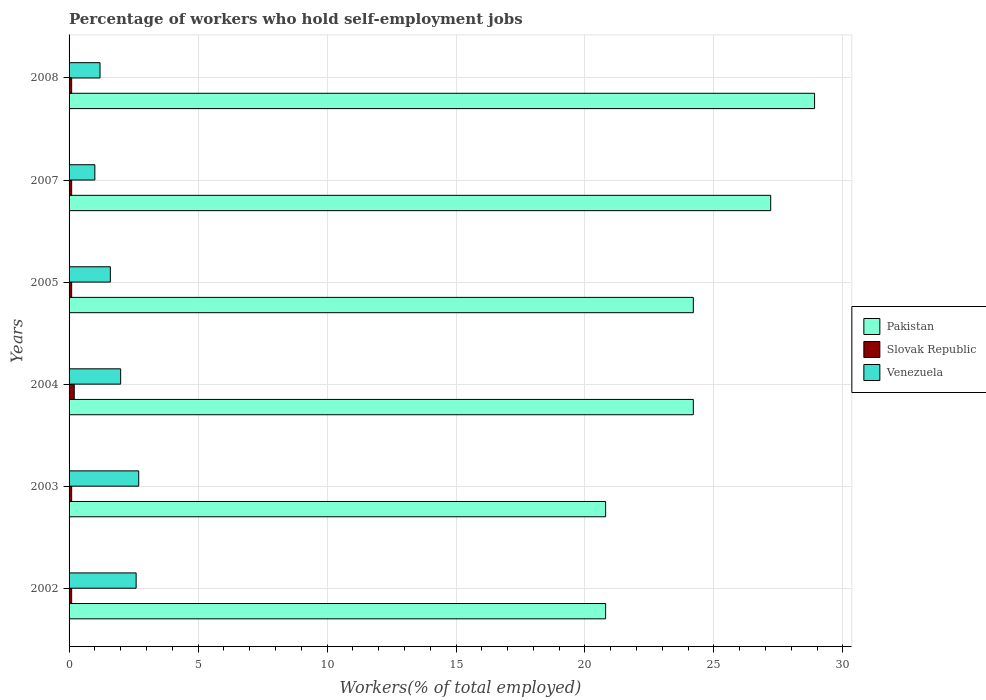How many different coloured bars are there?
Your response must be concise. 3. Are the number of bars per tick equal to the number of legend labels?
Ensure brevity in your answer.  Yes. How many bars are there on the 3rd tick from the top?
Your response must be concise. 3. What is the label of the 5th group of bars from the top?
Provide a succinct answer. 2003. In how many cases, is the number of bars for a given year not equal to the number of legend labels?
Offer a terse response. 0. What is the percentage of self-employed workers in Slovak Republic in 2003?
Make the answer very short. 0.1. Across all years, what is the maximum percentage of self-employed workers in Slovak Republic?
Offer a terse response. 0.2. Across all years, what is the minimum percentage of self-employed workers in Venezuela?
Your response must be concise. 1. In which year was the percentage of self-employed workers in Pakistan maximum?
Your answer should be compact. 2008. What is the total percentage of self-employed workers in Slovak Republic in the graph?
Ensure brevity in your answer.  0.7. What is the difference between the percentage of self-employed workers in Pakistan in 2002 and that in 2003?
Make the answer very short. 0. What is the difference between the percentage of self-employed workers in Pakistan in 2004 and the percentage of self-employed workers in Venezuela in 2005?
Make the answer very short. 22.6. What is the average percentage of self-employed workers in Pakistan per year?
Make the answer very short. 24.35. In the year 2008, what is the difference between the percentage of self-employed workers in Pakistan and percentage of self-employed workers in Venezuela?
Ensure brevity in your answer.  27.7. In how many years, is the percentage of self-employed workers in Pakistan greater than 3 %?
Offer a very short reply. 6. What is the ratio of the percentage of self-employed workers in Pakistan in 2005 to that in 2007?
Provide a short and direct response. 0.89. Is the percentage of self-employed workers in Slovak Republic in 2004 less than that in 2005?
Provide a succinct answer. No. Is the difference between the percentage of self-employed workers in Pakistan in 2004 and 2008 greater than the difference between the percentage of self-employed workers in Venezuela in 2004 and 2008?
Ensure brevity in your answer.  No. What is the difference between the highest and the second highest percentage of self-employed workers in Slovak Republic?
Your response must be concise. 0.1. What is the difference between the highest and the lowest percentage of self-employed workers in Venezuela?
Make the answer very short. 1.7. In how many years, is the percentage of self-employed workers in Slovak Republic greater than the average percentage of self-employed workers in Slovak Republic taken over all years?
Make the answer very short. 1. Is the sum of the percentage of self-employed workers in Pakistan in 2005 and 2008 greater than the maximum percentage of self-employed workers in Venezuela across all years?
Your answer should be very brief. Yes. What does the 3rd bar from the bottom in 2004 represents?
Your answer should be compact. Venezuela. How many bars are there?
Provide a short and direct response. 18. Does the graph contain any zero values?
Your answer should be compact. No. Does the graph contain grids?
Provide a short and direct response. Yes. What is the title of the graph?
Your answer should be compact. Percentage of workers who hold self-employment jobs. What is the label or title of the X-axis?
Provide a short and direct response. Workers(% of total employed). What is the Workers(% of total employed) in Pakistan in 2002?
Ensure brevity in your answer.  20.8. What is the Workers(% of total employed) of Slovak Republic in 2002?
Offer a terse response. 0.1. What is the Workers(% of total employed) of Venezuela in 2002?
Make the answer very short. 2.6. What is the Workers(% of total employed) in Pakistan in 2003?
Offer a very short reply. 20.8. What is the Workers(% of total employed) in Slovak Republic in 2003?
Provide a succinct answer. 0.1. What is the Workers(% of total employed) in Venezuela in 2003?
Offer a very short reply. 2.7. What is the Workers(% of total employed) in Pakistan in 2004?
Keep it short and to the point. 24.2. What is the Workers(% of total employed) in Slovak Republic in 2004?
Offer a terse response. 0.2. What is the Workers(% of total employed) of Pakistan in 2005?
Offer a terse response. 24.2. What is the Workers(% of total employed) in Slovak Republic in 2005?
Provide a short and direct response. 0.1. What is the Workers(% of total employed) of Venezuela in 2005?
Your answer should be very brief. 1.6. What is the Workers(% of total employed) in Pakistan in 2007?
Offer a very short reply. 27.2. What is the Workers(% of total employed) in Slovak Republic in 2007?
Your answer should be compact. 0.1. What is the Workers(% of total employed) of Venezuela in 2007?
Provide a succinct answer. 1. What is the Workers(% of total employed) of Pakistan in 2008?
Make the answer very short. 28.9. What is the Workers(% of total employed) in Slovak Republic in 2008?
Provide a succinct answer. 0.1. What is the Workers(% of total employed) in Venezuela in 2008?
Provide a short and direct response. 1.2. Across all years, what is the maximum Workers(% of total employed) in Pakistan?
Keep it short and to the point. 28.9. Across all years, what is the maximum Workers(% of total employed) of Slovak Republic?
Provide a short and direct response. 0.2. Across all years, what is the maximum Workers(% of total employed) of Venezuela?
Your answer should be compact. 2.7. Across all years, what is the minimum Workers(% of total employed) in Pakistan?
Give a very brief answer. 20.8. Across all years, what is the minimum Workers(% of total employed) of Slovak Republic?
Give a very brief answer. 0.1. What is the total Workers(% of total employed) in Pakistan in the graph?
Give a very brief answer. 146.1. What is the total Workers(% of total employed) in Slovak Republic in the graph?
Your answer should be very brief. 0.7. What is the difference between the Workers(% of total employed) of Slovak Republic in 2002 and that in 2003?
Provide a succinct answer. 0. What is the difference between the Workers(% of total employed) of Pakistan in 2002 and that in 2004?
Your answer should be very brief. -3.4. What is the difference between the Workers(% of total employed) of Venezuela in 2002 and that in 2004?
Your response must be concise. 0.6. What is the difference between the Workers(% of total employed) of Slovak Republic in 2002 and that in 2005?
Ensure brevity in your answer.  0. What is the difference between the Workers(% of total employed) of Pakistan in 2002 and that in 2007?
Offer a very short reply. -6.4. What is the difference between the Workers(% of total employed) in Slovak Republic in 2002 and that in 2007?
Provide a short and direct response. 0. What is the difference between the Workers(% of total employed) in Slovak Republic in 2002 and that in 2008?
Provide a short and direct response. 0. What is the difference between the Workers(% of total employed) of Venezuela in 2003 and that in 2004?
Provide a short and direct response. 0.7. What is the difference between the Workers(% of total employed) of Slovak Republic in 2003 and that in 2005?
Provide a succinct answer. 0. What is the difference between the Workers(% of total employed) in Venezuela in 2003 and that in 2005?
Your response must be concise. 1.1. What is the difference between the Workers(% of total employed) in Pakistan in 2003 and that in 2007?
Keep it short and to the point. -6.4. What is the difference between the Workers(% of total employed) of Slovak Republic in 2003 and that in 2007?
Offer a terse response. 0. What is the difference between the Workers(% of total employed) in Venezuela in 2003 and that in 2008?
Your answer should be very brief. 1.5. What is the difference between the Workers(% of total employed) in Pakistan in 2004 and that in 2005?
Ensure brevity in your answer.  0. What is the difference between the Workers(% of total employed) in Slovak Republic in 2004 and that in 2005?
Give a very brief answer. 0.1. What is the difference between the Workers(% of total employed) in Venezuela in 2004 and that in 2005?
Your answer should be very brief. 0.4. What is the difference between the Workers(% of total employed) of Venezuela in 2004 and that in 2007?
Provide a short and direct response. 1. What is the difference between the Workers(% of total employed) in Pakistan in 2004 and that in 2008?
Keep it short and to the point. -4.7. What is the difference between the Workers(% of total employed) of Slovak Republic in 2004 and that in 2008?
Your answer should be very brief. 0.1. What is the difference between the Workers(% of total employed) in Pakistan in 2005 and that in 2007?
Ensure brevity in your answer.  -3. What is the difference between the Workers(% of total employed) in Slovak Republic in 2005 and that in 2007?
Your answer should be compact. 0. What is the difference between the Workers(% of total employed) in Pakistan in 2005 and that in 2008?
Keep it short and to the point. -4.7. What is the difference between the Workers(% of total employed) in Pakistan in 2007 and that in 2008?
Offer a terse response. -1.7. What is the difference between the Workers(% of total employed) in Slovak Republic in 2007 and that in 2008?
Provide a short and direct response. 0. What is the difference between the Workers(% of total employed) in Venezuela in 2007 and that in 2008?
Provide a succinct answer. -0.2. What is the difference between the Workers(% of total employed) in Pakistan in 2002 and the Workers(% of total employed) in Slovak Republic in 2003?
Provide a succinct answer. 20.7. What is the difference between the Workers(% of total employed) in Pakistan in 2002 and the Workers(% of total employed) in Slovak Republic in 2004?
Your answer should be compact. 20.6. What is the difference between the Workers(% of total employed) in Pakistan in 2002 and the Workers(% of total employed) in Slovak Republic in 2005?
Make the answer very short. 20.7. What is the difference between the Workers(% of total employed) in Pakistan in 2002 and the Workers(% of total employed) in Slovak Republic in 2007?
Offer a terse response. 20.7. What is the difference between the Workers(% of total employed) of Pakistan in 2002 and the Workers(% of total employed) of Venezuela in 2007?
Your response must be concise. 19.8. What is the difference between the Workers(% of total employed) of Slovak Republic in 2002 and the Workers(% of total employed) of Venezuela in 2007?
Provide a short and direct response. -0.9. What is the difference between the Workers(% of total employed) of Pakistan in 2002 and the Workers(% of total employed) of Slovak Republic in 2008?
Your answer should be compact. 20.7. What is the difference between the Workers(% of total employed) in Pakistan in 2002 and the Workers(% of total employed) in Venezuela in 2008?
Your answer should be compact. 19.6. What is the difference between the Workers(% of total employed) of Pakistan in 2003 and the Workers(% of total employed) of Slovak Republic in 2004?
Your response must be concise. 20.6. What is the difference between the Workers(% of total employed) of Pakistan in 2003 and the Workers(% of total employed) of Slovak Republic in 2005?
Your answer should be very brief. 20.7. What is the difference between the Workers(% of total employed) of Pakistan in 2003 and the Workers(% of total employed) of Venezuela in 2005?
Keep it short and to the point. 19.2. What is the difference between the Workers(% of total employed) of Slovak Republic in 2003 and the Workers(% of total employed) of Venezuela in 2005?
Offer a terse response. -1.5. What is the difference between the Workers(% of total employed) of Pakistan in 2003 and the Workers(% of total employed) of Slovak Republic in 2007?
Provide a succinct answer. 20.7. What is the difference between the Workers(% of total employed) in Pakistan in 2003 and the Workers(% of total employed) in Venezuela in 2007?
Make the answer very short. 19.8. What is the difference between the Workers(% of total employed) in Slovak Republic in 2003 and the Workers(% of total employed) in Venezuela in 2007?
Provide a succinct answer. -0.9. What is the difference between the Workers(% of total employed) of Pakistan in 2003 and the Workers(% of total employed) of Slovak Republic in 2008?
Give a very brief answer. 20.7. What is the difference between the Workers(% of total employed) of Pakistan in 2003 and the Workers(% of total employed) of Venezuela in 2008?
Give a very brief answer. 19.6. What is the difference between the Workers(% of total employed) of Slovak Republic in 2003 and the Workers(% of total employed) of Venezuela in 2008?
Offer a very short reply. -1.1. What is the difference between the Workers(% of total employed) in Pakistan in 2004 and the Workers(% of total employed) in Slovak Republic in 2005?
Offer a terse response. 24.1. What is the difference between the Workers(% of total employed) in Pakistan in 2004 and the Workers(% of total employed) in Venezuela in 2005?
Make the answer very short. 22.6. What is the difference between the Workers(% of total employed) of Slovak Republic in 2004 and the Workers(% of total employed) of Venezuela in 2005?
Provide a short and direct response. -1.4. What is the difference between the Workers(% of total employed) in Pakistan in 2004 and the Workers(% of total employed) in Slovak Republic in 2007?
Offer a terse response. 24.1. What is the difference between the Workers(% of total employed) in Pakistan in 2004 and the Workers(% of total employed) in Venezuela in 2007?
Your answer should be compact. 23.2. What is the difference between the Workers(% of total employed) in Pakistan in 2004 and the Workers(% of total employed) in Slovak Republic in 2008?
Your response must be concise. 24.1. What is the difference between the Workers(% of total employed) in Pakistan in 2004 and the Workers(% of total employed) in Venezuela in 2008?
Provide a short and direct response. 23. What is the difference between the Workers(% of total employed) in Pakistan in 2005 and the Workers(% of total employed) in Slovak Republic in 2007?
Give a very brief answer. 24.1. What is the difference between the Workers(% of total employed) of Pakistan in 2005 and the Workers(% of total employed) of Venezuela in 2007?
Your answer should be very brief. 23.2. What is the difference between the Workers(% of total employed) of Pakistan in 2005 and the Workers(% of total employed) of Slovak Republic in 2008?
Make the answer very short. 24.1. What is the difference between the Workers(% of total employed) of Pakistan in 2007 and the Workers(% of total employed) of Slovak Republic in 2008?
Make the answer very short. 27.1. What is the difference between the Workers(% of total employed) of Pakistan in 2007 and the Workers(% of total employed) of Venezuela in 2008?
Provide a short and direct response. 26. What is the difference between the Workers(% of total employed) in Slovak Republic in 2007 and the Workers(% of total employed) in Venezuela in 2008?
Provide a succinct answer. -1.1. What is the average Workers(% of total employed) of Pakistan per year?
Your answer should be very brief. 24.35. What is the average Workers(% of total employed) in Slovak Republic per year?
Your answer should be compact. 0.12. What is the average Workers(% of total employed) in Venezuela per year?
Offer a terse response. 1.85. In the year 2002, what is the difference between the Workers(% of total employed) of Pakistan and Workers(% of total employed) of Slovak Republic?
Keep it short and to the point. 20.7. In the year 2003, what is the difference between the Workers(% of total employed) of Pakistan and Workers(% of total employed) of Slovak Republic?
Provide a short and direct response. 20.7. In the year 2003, what is the difference between the Workers(% of total employed) in Pakistan and Workers(% of total employed) in Venezuela?
Offer a very short reply. 18.1. In the year 2004, what is the difference between the Workers(% of total employed) in Slovak Republic and Workers(% of total employed) in Venezuela?
Your answer should be very brief. -1.8. In the year 2005, what is the difference between the Workers(% of total employed) of Pakistan and Workers(% of total employed) of Slovak Republic?
Make the answer very short. 24.1. In the year 2005, what is the difference between the Workers(% of total employed) in Pakistan and Workers(% of total employed) in Venezuela?
Make the answer very short. 22.6. In the year 2005, what is the difference between the Workers(% of total employed) in Slovak Republic and Workers(% of total employed) in Venezuela?
Make the answer very short. -1.5. In the year 2007, what is the difference between the Workers(% of total employed) in Pakistan and Workers(% of total employed) in Slovak Republic?
Keep it short and to the point. 27.1. In the year 2007, what is the difference between the Workers(% of total employed) of Pakistan and Workers(% of total employed) of Venezuela?
Give a very brief answer. 26.2. In the year 2008, what is the difference between the Workers(% of total employed) in Pakistan and Workers(% of total employed) in Slovak Republic?
Your answer should be very brief. 28.8. In the year 2008, what is the difference between the Workers(% of total employed) of Pakistan and Workers(% of total employed) of Venezuela?
Your answer should be compact. 27.7. What is the ratio of the Workers(% of total employed) of Slovak Republic in 2002 to that in 2003?
Your answer should be compact. 1. What is the ratio of the Workers(% of total employed) in Pakistan in 2002 to that in 2004?
Your answer should be compact. 0.86. What is the ratio of the Workers(% of total employed) of Slovak Republic in 2002 to that in 2004?
Provide a short and direct response. 0.5. What is the ratio of the Workers(% of total employed) of Pakistan in 2002 to that in 2005?
Keep it short and to the point. 0.86. What is the ratio of the Workers(% of total employed) in Slovak Republic in 2002 to that in 2005?
Give a very brief answer. 1. What is the ratio of the Workers(% of total employed) of Venezuela in 2002 to that in 2005?
Provide a short and direct response. 1.62. What is the ratio of the Workers(% of total employed) of Pakistan in 2002 to that in 2007?
Keep it short and to the point. 0.76. What is the ratio of the Workers(% of total employed) of Slovak Republic in 2002 to that in 2007?
Offer a terse response. 1. What is the ratio of the Workers(% of total employed) of Venezuela in 2002 to that in 2007?
Offer a very short reply. 2.6. What is the ratio of the Workers(% of total employed) of Pakistan in 2002 to that in 2008?
Your answer should be compact. 0.72. What is the ratio of the Workers(% of total employed) in Venezuela in 2002 to that in 2008?
Provide a succinct answer. 2.17. What is the ratio of the Workers(% of total employed) of Pakistan in 2003 to that in 2004?
Keep it short and to the point. 0.86. What is the ratio of the Workers(% of total employed) in Venezuela in 2003 to that in 2004?
Your response must be concise. 1.35. What is the ratio of the Workers(% of total employed) in Pakistan in 2003 to that in 2005?
Ensure brevity in your answer.  0.86. What is the ratio of the Workers(% of total employed) of Slovak Republic in 2003 to that in 2005?
Ensure brevity in your answer.  1. What is the ratio of the Workers(% of total employed) in Venezuela in 2003 to that in 2005?
Keep it short and to the point. 1.69. What is the ratio of the Workers(% of total employed) of Pakistan in 2003 to that in 2007?
Provide a short and direct response. 0.76. What is the ratio of the Workers(% of total employed) in Venezuela in 2003 to that in 2007?
Give a very brief answer. 2.7. What is the ratio of the Workers(% of total employed) in Pakistan in 2003 to that in 2008?
Provide a succinct answer. 0.72. What is the ratio of the Workers(% of total employed) of Slovak Republic in 2003 to that in 2008?
Offer a very short reply. 1. What is the ratio of the Workers(% of total employed) of Venezuela in 2003 to that in 2008?
Keep it short and to the point. 2.25. What is the ratio of the Workers(% of total employed) in Pakistan in 2004 to that in 2005?
Your answer should be very brief. 1. What is the ratio of the Workers(% of total employed) in Pakistan in 2004 to that in 2007?
Your response must be concise. 0.89. What is the ratio of the Workers(% of total employed) of Slovak Republic in 2004 to that in 2007?
Ensure brevity in your answer.  2. What is the ratio of the Workers(% of total employed) in Venezuela in 2004 to that in 2007?
Provide a short and direct response. 2. What is the ratio of the Workers(% of total employed) in Pakistan in 2004 to that in 2008?
Keep it short and to the point. 0.84. What is the ratio of the Workers(% of total employed) in Venezuela in 2004 to that in 2008?
Provide a succinct answer. 1.67. What is the ratio of the Workers(% of total employed) of Pakistan in 2005 to that in 2007?
Your answer should be compact. 0.89. What is the ratio of the Workers(% of total employed) of Pakistan in 2005 to that in 2008?
Provide a succinct answer. 0.84. What is the ratio of the Workers(% of total employed) of Venezuela in 2005 to that in 2008?
Your answer should be very brief. 1.33. What is the difference between the highest and the second highest Workers(% of total employed) of Slovak Republic?
Your response must be concise. 0.1. What is the difference between the highest and the lowest Workers(% of total employed) of Slovak Republic?
Your answer should be very brief. 0.1. 